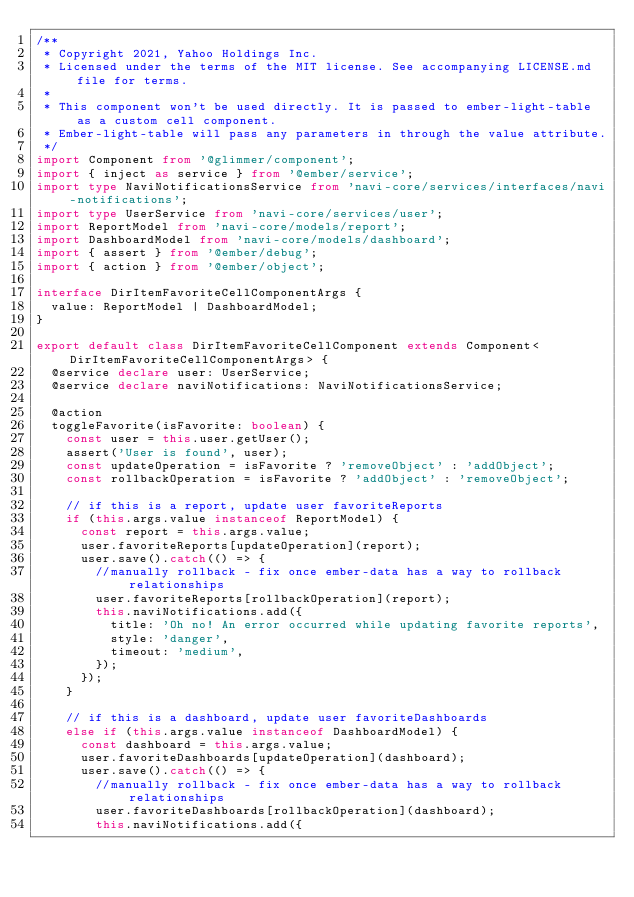<code> <loc_0><loc_0><loc_500><loc_500><_TypeScript_>/**
 * Copyright 2021, Yahoo Holdings Inc.
 * Licensed under the terms of the MIT license. See accompanying LICENSE.md file for terms.
 *
 * This component won't be used directly. It is passed to ember-light-table as a custom cell component.
 * Ember-light-table will pass any parameters in through the value attribute.
 */
import Component from '@glimmer/component';
import { inject as service } from '@ember/service';
import type NaviNotificationsService from 'navi-core/services/interfaces/navi-notifications';
import type UserService from 'navi-core/services/user';
import ReportModel from 'navi-core/models/report';
import DashboardModel from 'navi-core/models/dashboard';
import { assert } from '@ember/debug';
import { action } from '@ember/object';

interface DirItemFavoriteCellComponentArgs {
  value: ReportModel | DashboardModel;
}

export default class DirItemFavoriteCellComponent extends Component<DirItemFavoriteCellComponentArgs> {
  @service declare user: UserService;
  @service declare naviNotifications: NaviNotificationsService;

  @action
  toggleFavorite(isFavorite: boolean) {
    const user = this.user.getUser();
    assert('User is found', user);
    const updateOperation = isFavorite ? 'removeObject' : 'addObject';
    const rollbackOperation = isFavorite ? 'addObject' : 'removeObject';

    // if this is a report, update user favoriteReports
    if (this.args.value instanceof ReportModel) {
      const report = this.args.value;
      user.favoriteReports[updateOperation](report);
      user.save().catch(() => {
        //manually rollback - fix once ember-data has a way to rollback relationships
        user.favoriteReports[rollbackOperation](report);
        this.naviNotifications.add({
          title: 'Oh no! An error occurred while updating favorite reports',
          style: 'danger',
          timeout: 'medium',
        });
      });
    }

    // if this is a dashboard, update user favoriteDashboards
    else if (this.args.value instanceof DashboardModel) {
      const dashboard = this.args.value;
      user.favoriteDashboards[updateOperation](dashboard);
      user.save().catch(() => {
        //manually rollback - fix once ember-data has a way to rollback relationships
        user.favoriteDashboards[rollbackOperation](dashboard);
        this.naviNotifications.add({</code> 